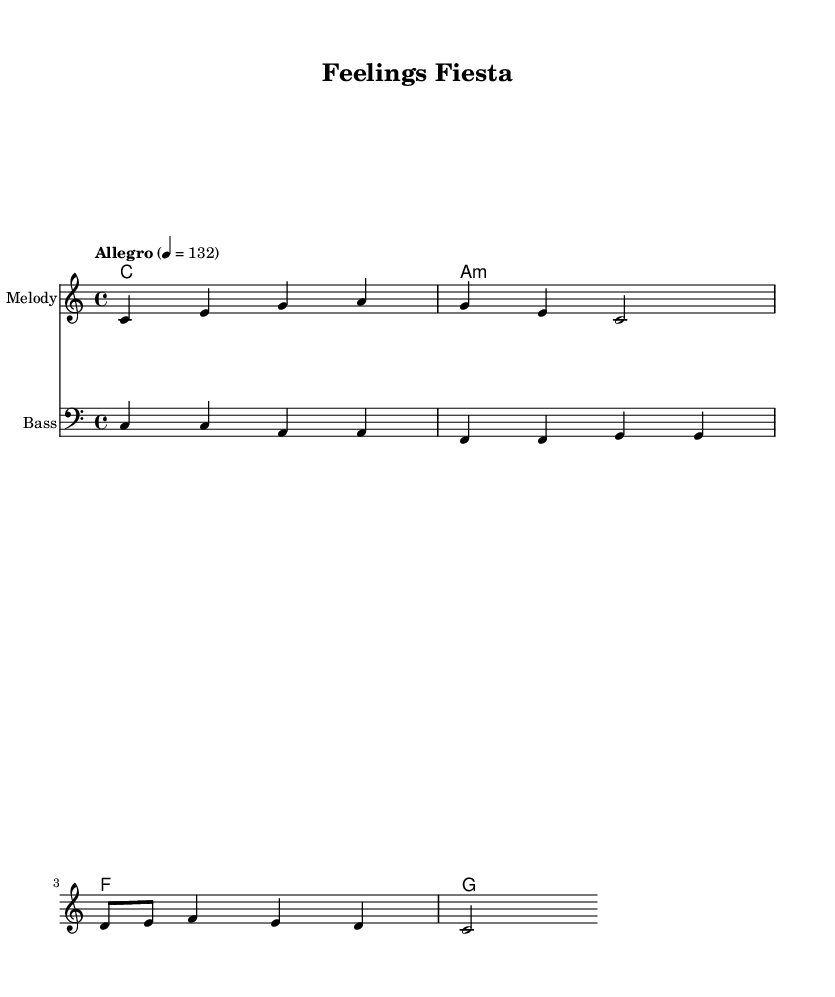What is the key signature of this music? The key signature is C major, which is indicated by the absence of any sharps or flats in the staff.
Answer: C major What is the time signature of the piece? The time signature is 4/4, which means there are four beats in each measure and the quarter note gets one beat.
Answer: 4/4 What is the tempo marking for this piece? The tempo marking is "Allegro," which suggests a quick and lively tempo of 132 beats per minute.
Answer: Allegro How many measures are present in the melody? The melody has a total of 6 measures, which can be counted by observing the placement of the bar lines in the notation.
Answer: 6 What are the primary emotions expressed in the lyrics? The emotions expressed in the lyrics are happy and sad, as these are the two emotions specifically mentioned in the text.
Answer: Happy, sad What instruments are represented in the score? The score includes two main staves labeled for "Melody" and "Bass," reflecting the voice of the melody and the bass line respectively.
Answer: Melody, Bass What genre does this piece represent? This piece represents Latin jazz fusion, characterized by its upbeat rhythm and incorporation of jazz elements with Latin music influences.
Answer: Latin jazz fusion 